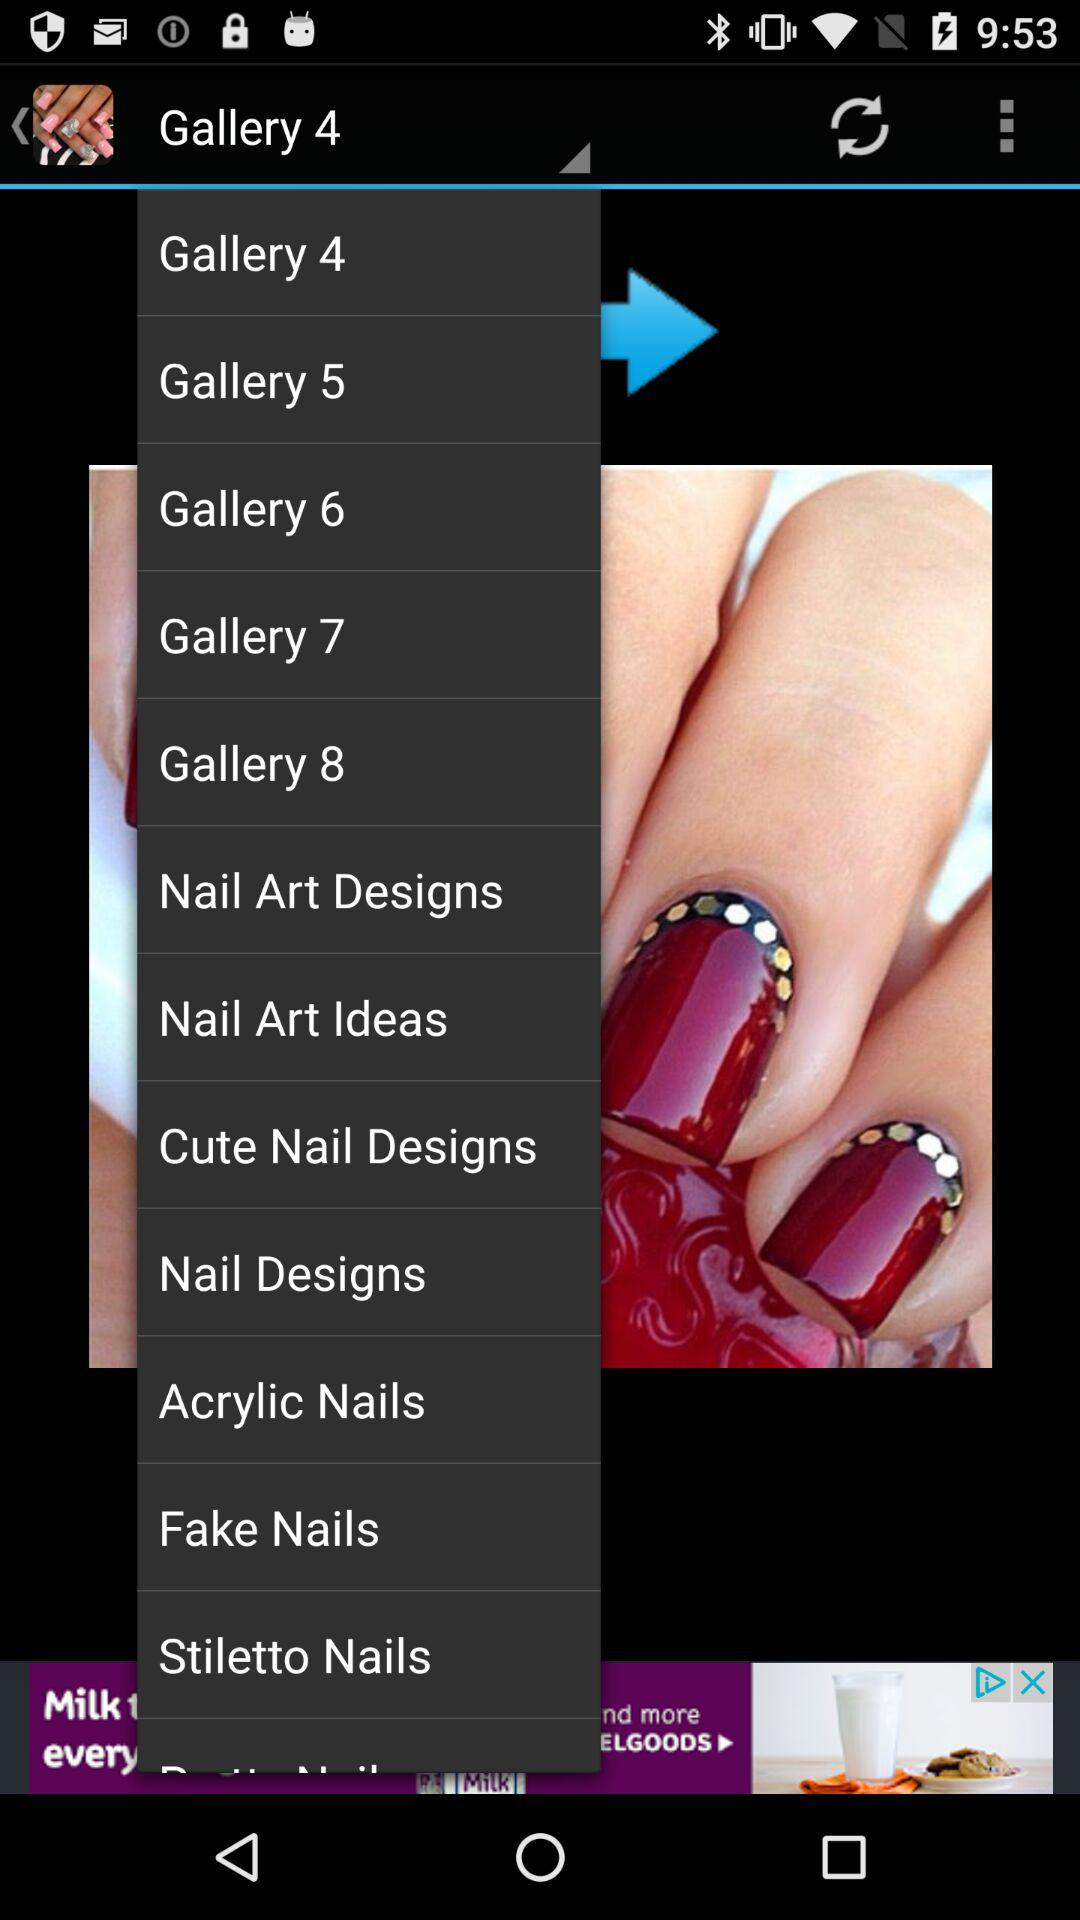Which option has been selected? The selected option is "Gallery 4". 